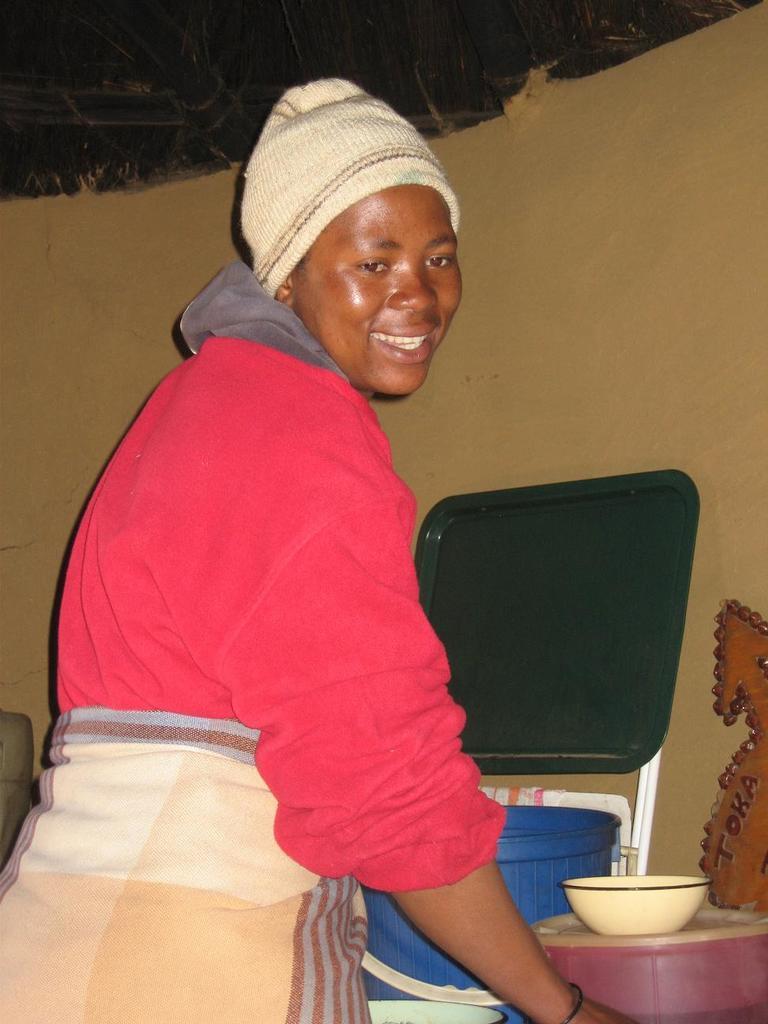In one or two sentences, can you explain what this image depicts? In the image we can see a person standing, wearing clothes and a cap. Here we can see a bowl, plastic objects and the wall. 